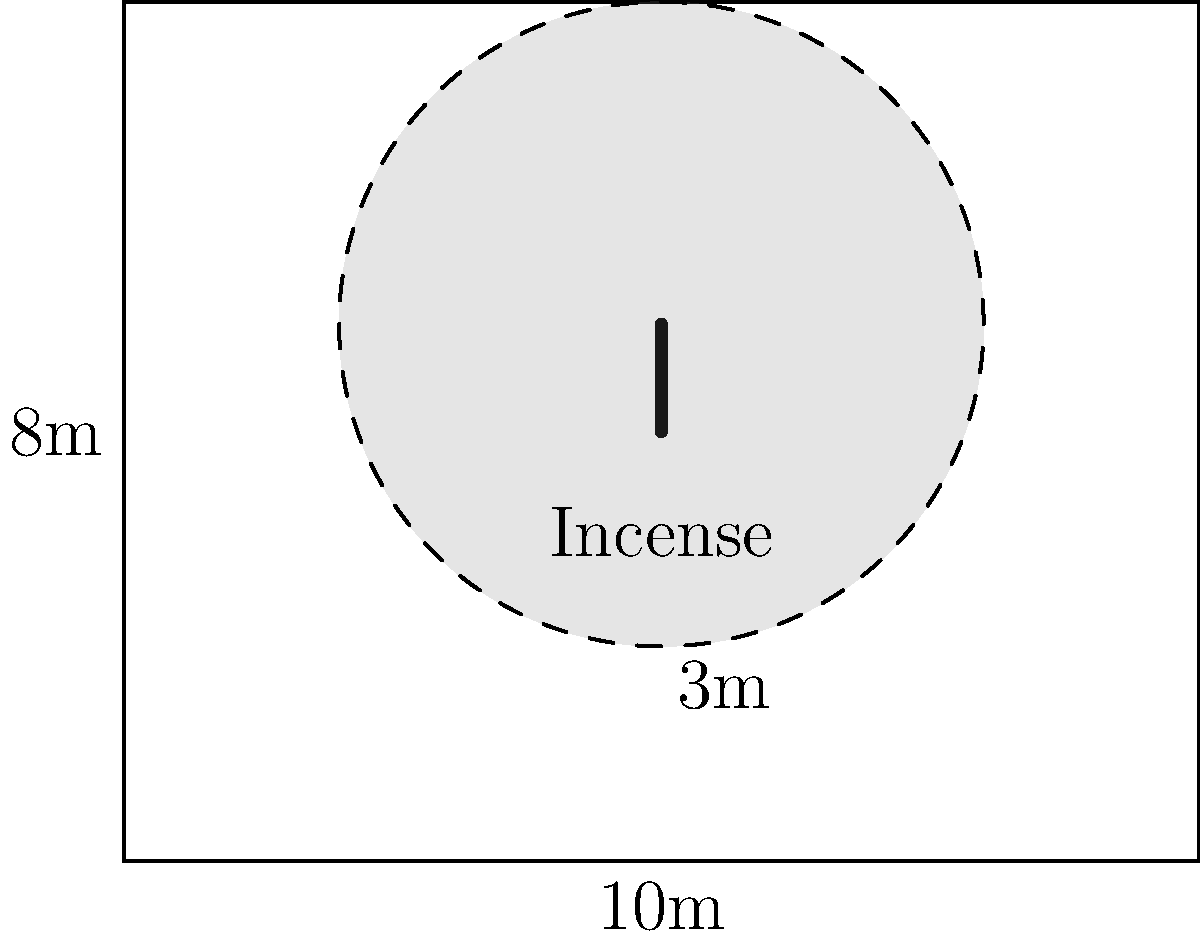In a rectangular meditation room measuring 10m by 8m, an incense stick is placed at the center. The smoke from the incense forms a circular pattern with a radius of 3m. What percentage of the room's floor area is covered by the incense smoke? To solve this problem, let's follow these steps:

1. Calculate the total area of the room:
   $A_{room} = 10m \times 8m = 80m^2$

2. Calculate the area of the circular smoke coverage:
   $A_{smoke} = \pi r^2 = \pi \times (3m)^2 = 9\pi m^2$

3. Calculate the percentage of the room covered by smoke:
   $\text{Percentage} = \frac{A_{smoke}}{A_{room}} \times 100\%$
   
   $= \frac{9\pi m^2}{80m^2} \times 100\%$
   
   $= \frac{9\pi}{80} \times 100\%$
   
   $\approx 35.34\%$

Therefore, the incense smoke covers approximately 35.34% of the room's floor area.
Answer: 35.34% 